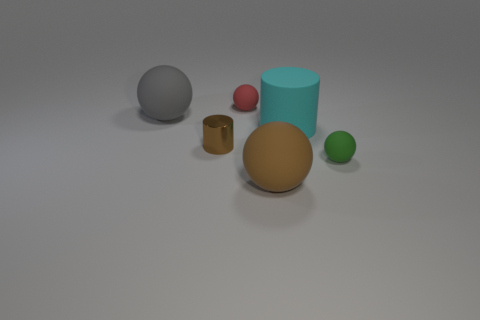Subtract all big gray rubber spheres. How many spheres are left? 3 Add 3 small gray matte spheres. How many objects exist? 9 Add 5 large objects. How many large objects are left? 8 Add 5 small yellow objects. How many small yellow objects exist? 5 Subtract all brown spheres. How many spheres are left? 3 Subtract 0 gray cubes. How many objects are left? 6 Subtract all balls. How many objects are left? 2 Subtract 2 cylinders. How many cylinders are left? 0 Subtract all gray balls. Subtract all gray cylinders. How many balls are left? 3 Subtract all brown cubes. How many gray balls are left? 1 